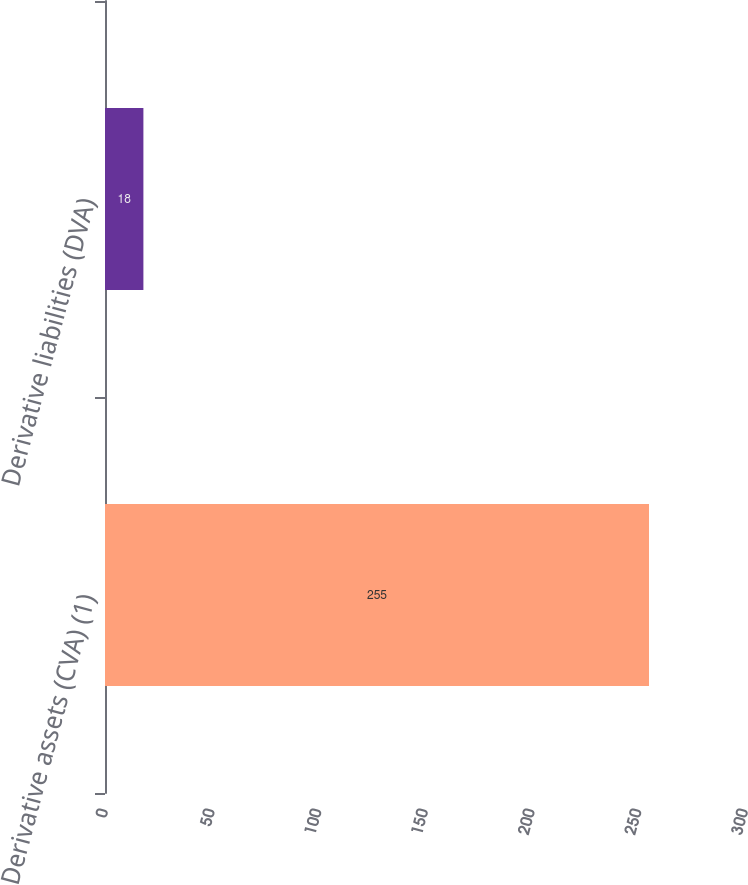Convert chart. <chart><loc_0><loc_0><loc_500><loc_500><bar_chart><fcel>Derivative assets (CVA) (1)<fcel>Derivative liabilities (DVA)<nl><fcel>255<fcel>18<nl></chart> 